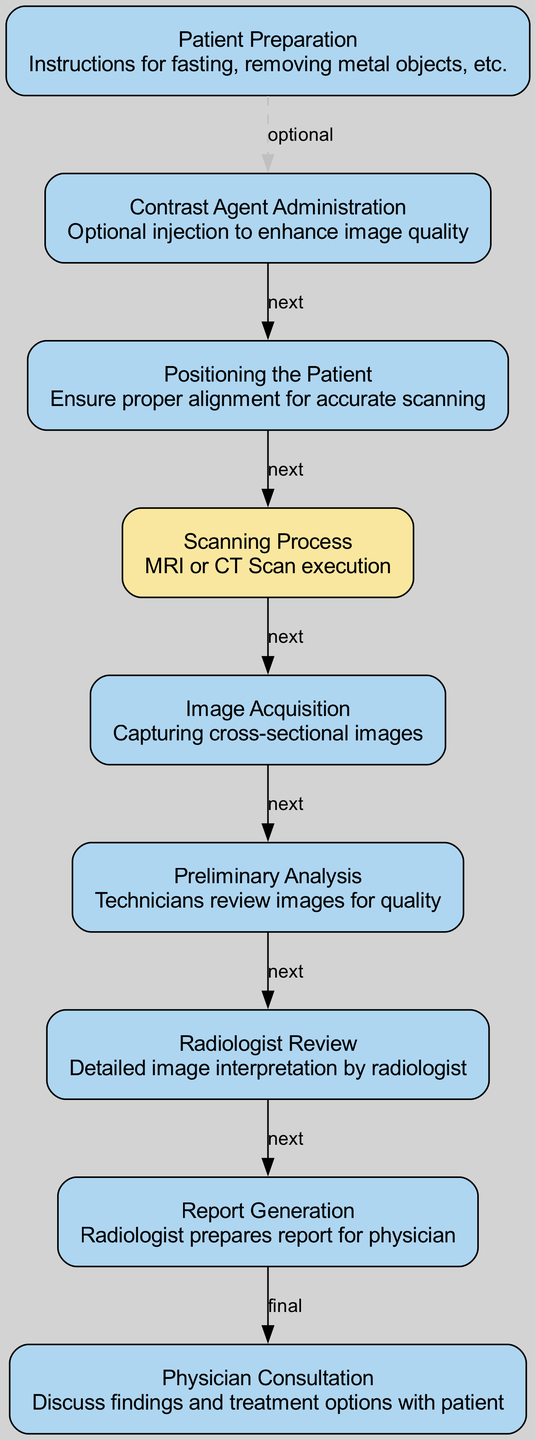What is the first step in the biomedical imaging process? The first step is labeled as "Patient Preparation" in the diagram. It describes the necessary instructions the patient must follow before the imaging process begins.
Answer: Patient Preparation How many total nodes are present in the diagram? Counting all the unique steps/nodes listed in the diagram, there are ten nodes, which include all major components from preparation to consultation.
Answer: 10 What is the visual distinction for the Scanning Process in the diagram? The "Scanning Process" node is highlighted with a different color (F9E79F) compared to other nodes (AED6F1), indicating its importance in the sequence of steps.
Answer: A distinct color What is the relationship between image acquisition and preliminary analysis? The relationship is labeled as "next," indicating that after image acquisition is completed, it proceeds directly to preliminary analysis for quality review.
Answer: next Which step is optional in the biomedical imaging process? The "Contrast Agent Administration" step is indicated as optional in the diagram, meaning it is not always necessary for the imaging process to be completed.
Answer: Contrast Agent Administration What is the final output of the process depicted in the diagram? The final output is "Physician Consultation," where the findings are discussed with the patient, concluding the imaging process.
Answer: Physician Consultation How does the process flow from the Scanning Process to Image Acquisition? The process flows with a direct connection labeled "next," indicating that once the scanning is complete, it directly transitions into image acquisition of cross-sectional images.
Answer: next Which step involves the technician's review of the images? "Preliminary Analysis" is the step where technicians review the images collected from the scanning process for quality assurance before further interpretation.
Answer: Preliminary Analysis What is the role of the radiologist in this process? The radiologist's role is to perform a detailed interpretation of the images obtained during the scanning, which follows the preliminary analysis step.
Answer: Detailed image interpretation 